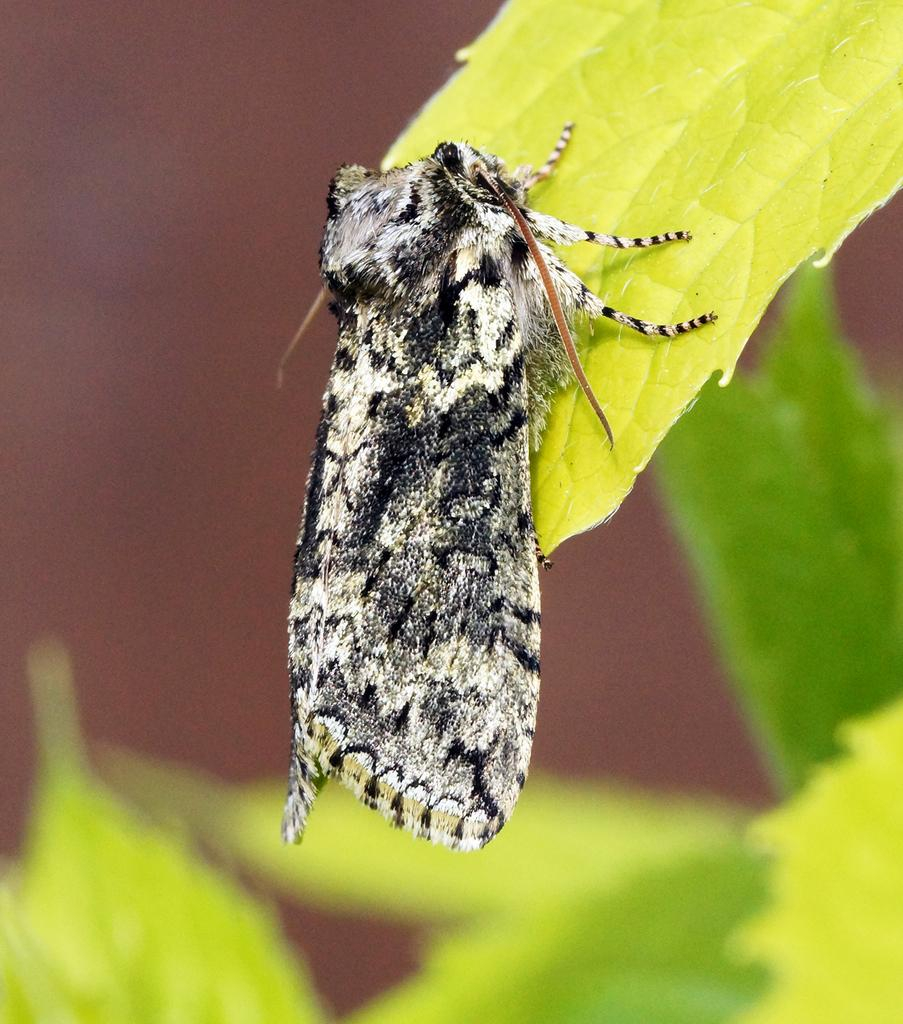What type of natural elements can be seen in the image? There are leaves in the image. What living organism is present in the image? There is an insect in the image. Can you describe the background of the image? The background of the image is blurred. How many babies are visible in the image? There are no babies present in the image. What type of stone can be seen in the image? There is no stone present in the image. 